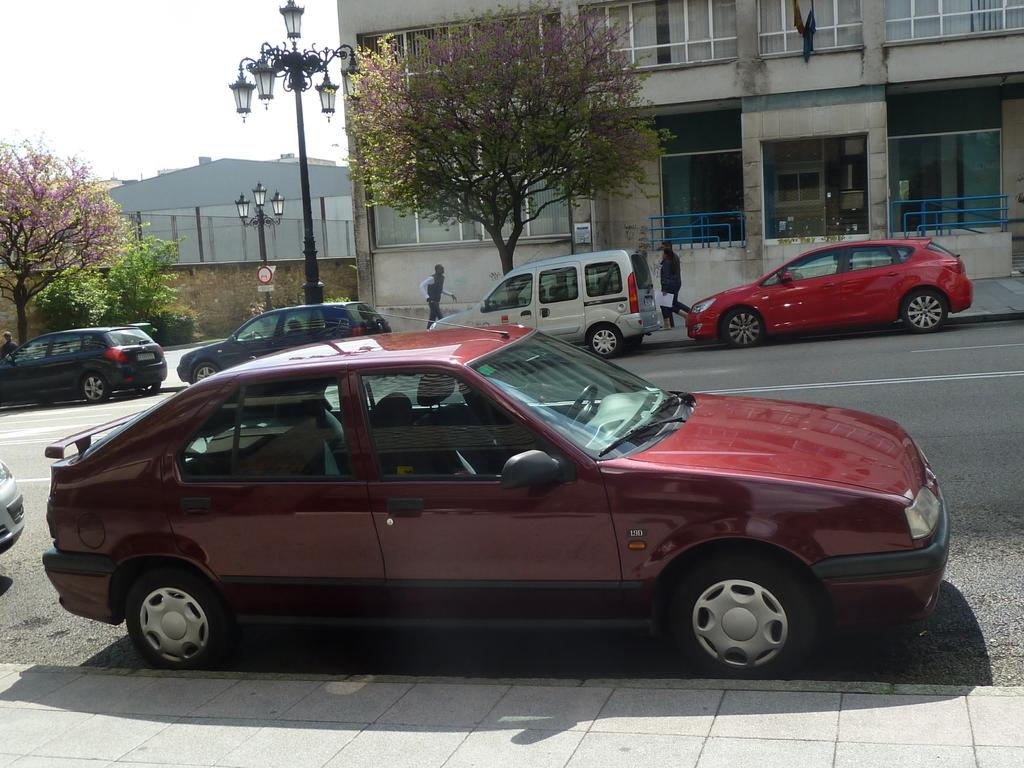What types of objects can be seen in the image? There are vehicles, buildings, trees, persons, boards, plants, and a wall visible in the image. Can you describe the setting of the image? The image features a combination of urban and natural elements, including buildings, trees, and plants. What is visible in the sky in the image? The sky is visible in the image. What type of pan is being used to attack the buildings in the image? There is no pan or attack present in the image; it features a peaceful scene with vehicles, buildings, trees, persons, boards, plants, and a wall. 